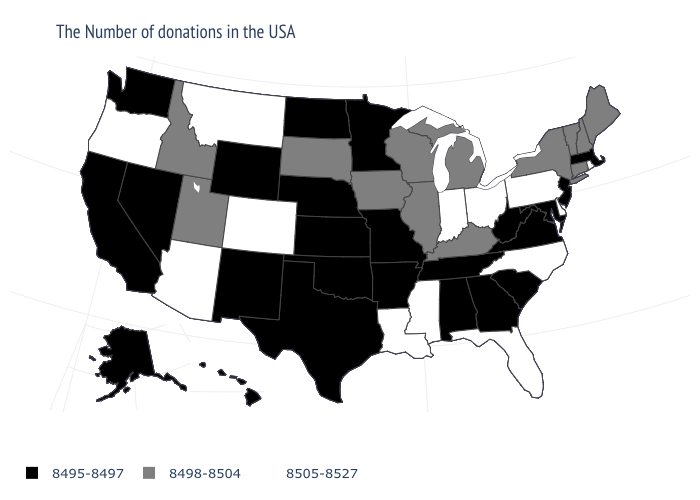Name the states that have a value in the range 8495-8497?
Quick response, please. Massachusetts, New Jersey, Maryland, Virginia, South Carolina, West Virginia, Georgia, Alabama, Tennessee, Missouri, Arkansas, Minnesota, Kansas, Nebraska, Oklahoma, Texas, North Dakota, Wyoming, New Mexico, Nevada, California, Washington, Alaska, Hawaii. Name the states that have a value in the range 8505-8527?
Answer briefly. Rhode Island, Delaware, Pennsylvania, North Carolina, Ohio, Florida, Indiana, Mississippi, Louisiana, Colorado, Montana, Arizona, Oregon. Does Colorado have the highest value in the USA?
Quick response, please. Yes. What is the value of South Dakota?
Quick response, please. 8498-8504. Is the legend a continuous bar?
Be succinct. No. How many symbols are there in the legend?
Quick response, please. 3. Does the first symbol in the legend represent the smallest category?
Short answer required. Yes. What is the value of Oregon?
Answer briefly. 8505-8527. Does the first symbol in the legend represent the smallest category?
Be succinct. Yes. Does the map have missing data?
Be succinct. No. Name the states that have a value in the range 8505-8527?
Short answer required. Rhode Island, Delaware, Pennsylvania, North Carolina, Ohio, Florida, Indiana, Mississippi, Louisiana, Colorado, Montana, Arizona, Oregon. Which states have the highest value in the USA?
Answer briefly. Rhode Island, Delaware, Pennsylvania, North Carolina, Ohio, Florida, Indiana, Mississippi, Louisiana, Colorado, Montana, Arizona, Oregon. What is the lowest value in the Northeast?
Short answer required. 8495-8497. Does Pennsylvania have the highest value in the USA?
Write a very short answer. Yes. 